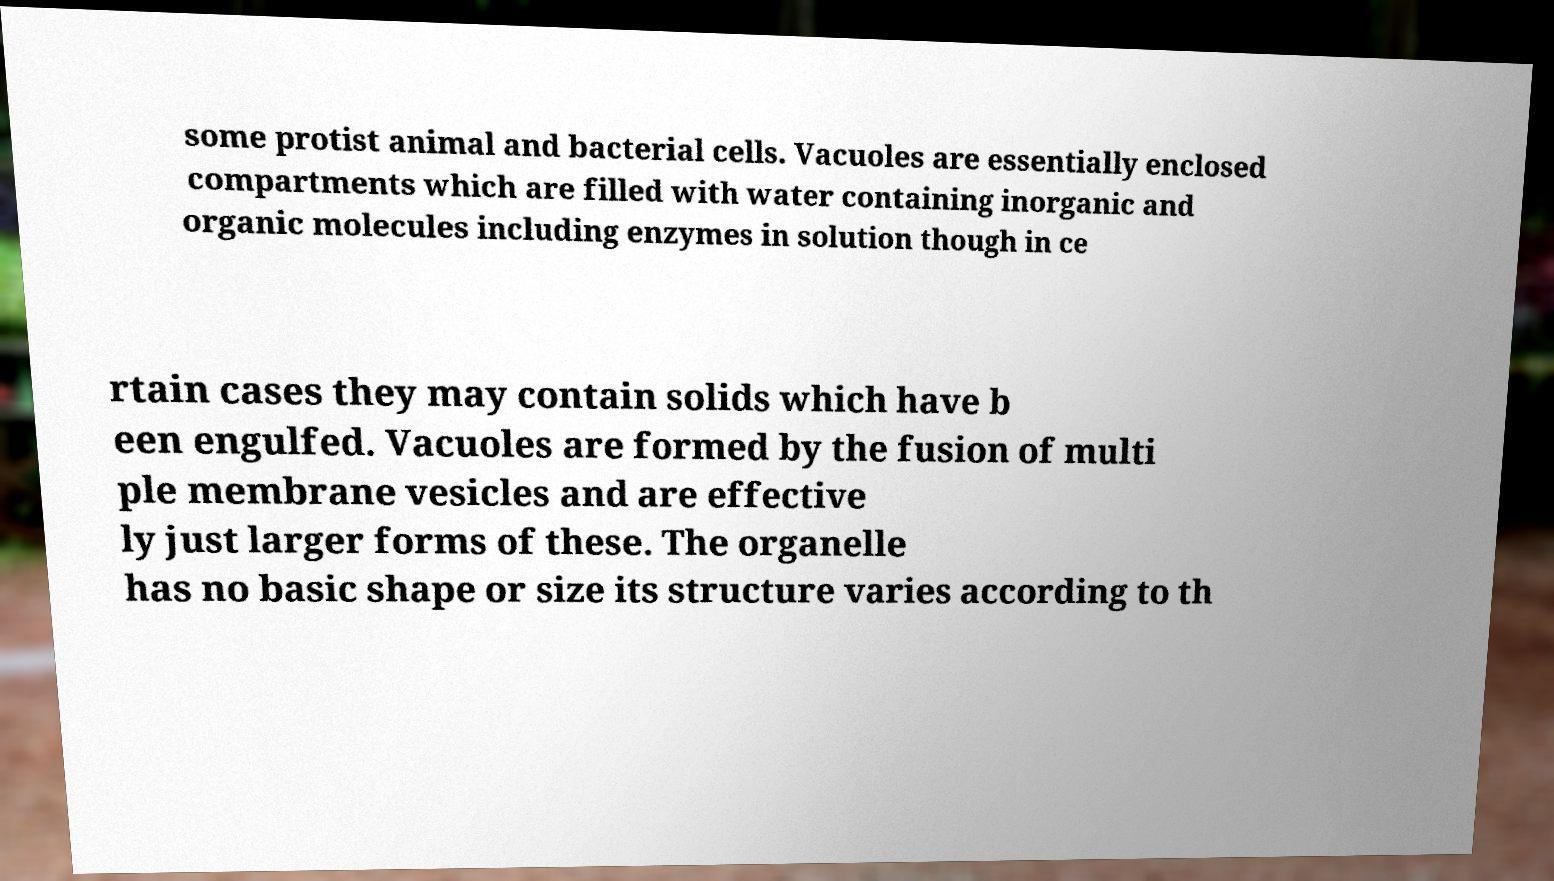Can you read and provide the text displayed in the image?This photo seems to have some interesting text. Can you extract and type it out for me? some protist animal and bacterial cells. Vacuoles are essentially enclosed compartments which are filled with water containing inorganic and organic molecules including enzymes in solution though in ce rtain cases they may contain solids which have b een engulfed. Vacuoles are formed by the fusion of multi ple membrane vesicles and are effective ly just larger forms of these. The organelle has no basic shape or size its structure varies according to th 